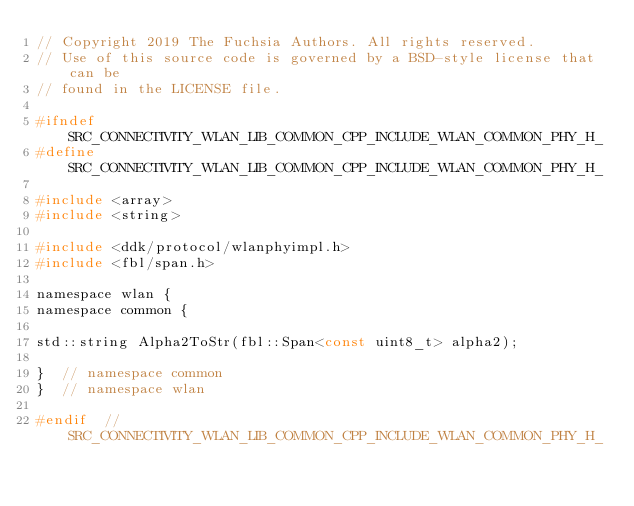<code> <loc_0><loc_0><loc_500><loc_500><_C_>// Copyright 2019 The Fuchsia Authors. All rights reserved.
// Use of this source code is governed by a BSD-style license that can be
// found in the LICENSE file.

#ifndef SRC_CONNECTIVITY_WLAN_LIB_COMMON_CPP_INCLUDE_WLAN_COMMON_PHY_H_
#define SRC_CONNECTIVITY_WLAN_LIB_COMMON_CPP_INCLUDE_WLAN_COMMON_PHY_H_

#include <array>
#include <string>

#include <ddk/protocol/wlanphyimpl.h>
#include <fbl/span.h>

namespace wlan {
namespace common {

std::string Alpha2ToStr(fbl::Span<const uint8_t> alpha2);

}  // namespace common
}  // namespace wlan

#endif  // SRC_CONNECTIVITY_WLAN_LIB_COMMON_CPP_INCLUDE_WLAN_COMMON_PHY_H_
</code> 